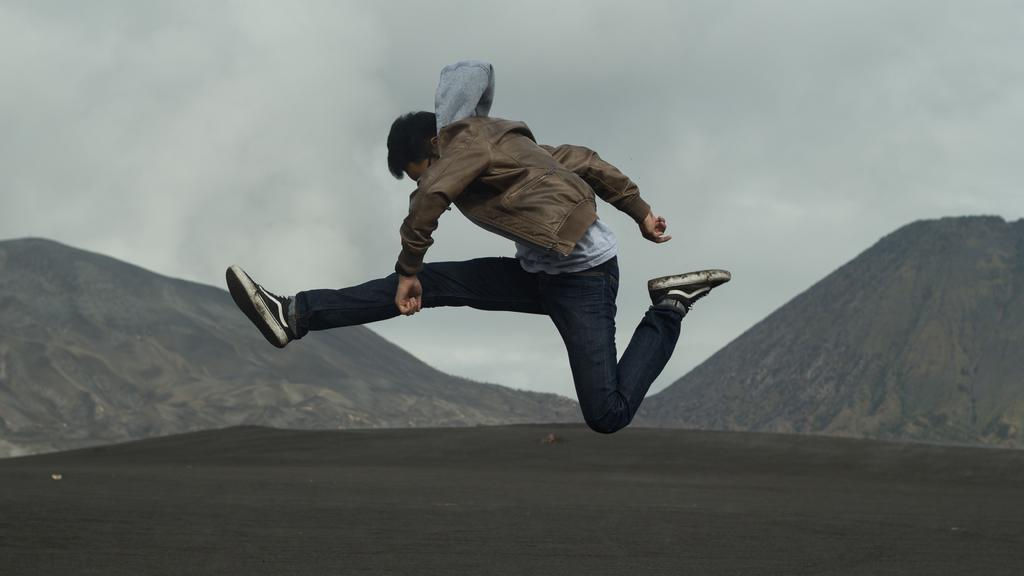What is the nature of the image? The image appears to be edited. What is the man in the image doing? The man is jumping in the image. What type of clothing is the man wearing on his upper body? The man is wearing a jerkin and a T-shirt. What type of clothing is the man wearing on his lower body? The man is wearing trousers. What type of footwear is the man wearing? The man is wearing shoes. What can be seen in the background of the image? There are hills in the background of the image. What is visible at the top of the image? The sky is visible in the image. What type of can is visible in the image? There is no can present in the image. How much sugar is visible in the image? There is no sugar present in the image. What type of kite is the man holding in the image? There is no kite present in the image. 